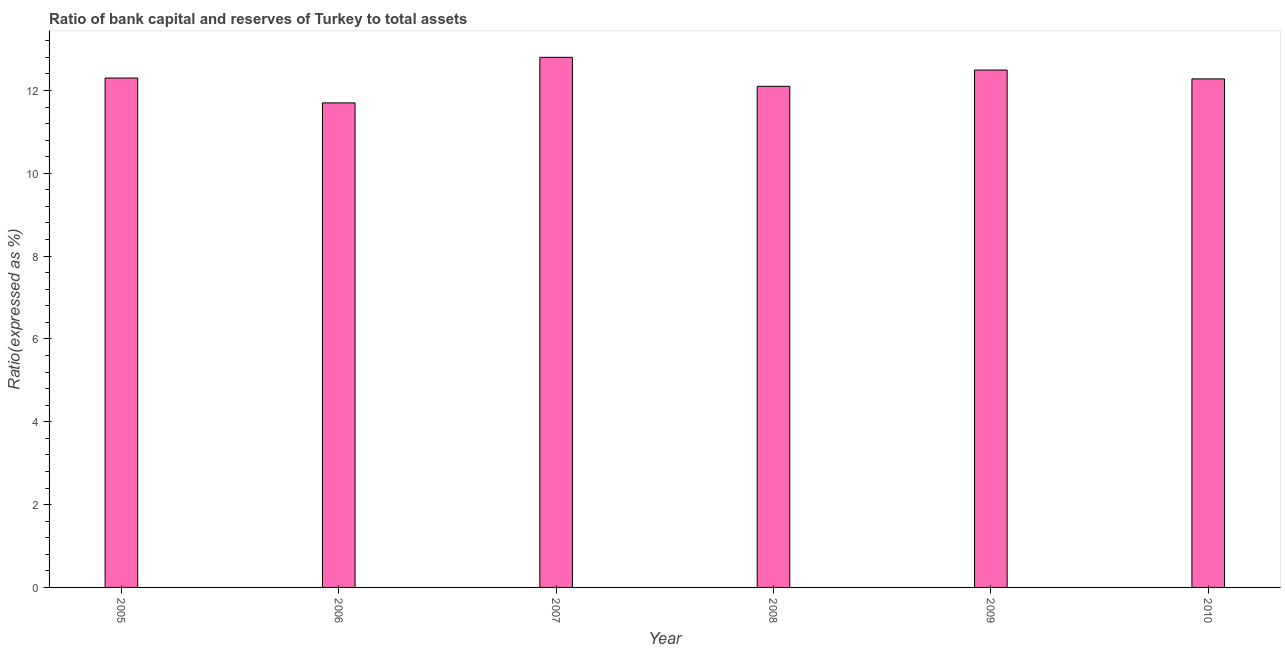Does the graph contain any zero values?
Offer a terse response. No. What is the title of the graph?
Your answer should be compact. Ratio of bank capital and reserves of Turkey to total assets. What is the label or title of the Y-axis?
Your answer should be very brief. Ratio(expressed as %). What is the bank capital to assets ratio in 2007?
Ensure brevity in your answer.  12.8. Across all years, what is the maximum bank capital to assets ratio?
Provide a short and direct response. 12.8. In which year was the bank capital to assets ratio maximum?
Make the answer very short. 2007. In which year was the bank capital to assets ratio minimum?
Provide a succinct answer. 2006. What is the sum of the bank capital to assets ratio?
Offer a very short reply. 73.67. What is the difference between the bank capital to assets ratio in 2007 and 2009?
Keep it short and to the point. 0.31. What is the average bank capital to assets ratio per year?
Provide a short and direct response. 12.28. What is the median bank capital to assets ratio?
Provide a succinct answer. 12.29. Do a majority of the years between 2009 and 2005 (inclusive) have bank capital to assets ratio greater than 9.2 %?
Keep it short and to the point. Yes. What is the difference between the highest and the second highest bank capital to assets ratio?
Your answer should be very brief. 0.31. Is the sum of the bank capital to assets ratio in 2005 and 2009 greater than the maximum bank capital to assets ratio across all years?
Provide a succinct answer. Yes. How many bars are there?
Your answer should be very brief. 6. How many years are there in the graph?
Provide a short and direct response. 6. What is the difference between two consecutive major ticks on the Y-axis?
Keep it short and to the point. 2. What is the Ratio(expressed as %) of 2005?
Your answer should be very brief. 12.3. What is the Ratio(expressed as %) in 2007?
Your answer should be very brief. 12.8. What is the Ratio(expressed as %) in 2009?
Provide a short and direct response. 12.49. What is the Ratio(expressed as %) of 2010?
Your response must be concise. 12.28. What is the difference between the Ratio(expressed as %) in 2005 and 2008?
Give a very brief answer. 0.2. What is the difference between the Ratio(expressed as %) in 2005 and 2009?
Your answer should be compact. -0.19. What is the difference between the Ratio(expressed as %) in 2005 and 2010?
Provide a succinct answer. 0.02. What is the difference between the Ratio(expressed as %) in 2006 and 2009?
Your answer should be compact. -0.79. What is the difference between the Ratio(expressed as %) in 2006 and 2010?
Keep it short and to the point. -0.58. What is the difference between the Ratio(expressed as %) in 2007 and 2009?
Offer a terse response. 0.31. What is the difference between the Ratio(expressed as %) in 2007 and 2010?
Provide a short and direct response. 0.52. What is the difference between the Ratio(expressed as %) in 2008 and 2009?
Offer a terse response. -0.39. What is the difference between the Ratio(expressed as %) in 2008 and 2010?
Offer a very short reply. -0.18. What is the difference between the Ratio(expressed as %) in 2009 and 2010?
Your answer should be very brief. 0.21. What is the ratio of the Ratio(expressed as %) in 2005 to that in 2006?
Provide a succinct answer. 1.05. What is the ratio of the Ratio(expressed as %) in 2005 to that in 2008?
Make the answer very short. 1.02. What is the ratio of the Ratio(expressed as %) in 2006 to that in 2007?
Offer a very short reply. 0.91. What is the ratio of the Ratio(expressed as %) in 2006 to that in 2008?
Provide a short and direct response. 0.97. What is the ratio of the Ratio(expressed as %) in 2006 to that in 2009?
Your answer should be compact. 0.94. What is the ratio of the Ratio(expressed as %) in 2006 to that in 2010?
Your answer should be very brief. 0.95. What is the ratio of the Ratio(expressed as %) in 2007 to that in 2008?
Your answer should be very brief. 1.06. What is the ratio of the Ratio(expressed as %) in 2007 to that in 2010?
Keep it short and to the point. 1.04. What is the ratio of the Ratio(expressed as %) in 2008 to that in 2010?
Your response must be concise. 0.98. What is the ratio of the Ratio(expressed as %) in 2009 to that in 2010?
Ensure brevity in your answer.  1.02. 